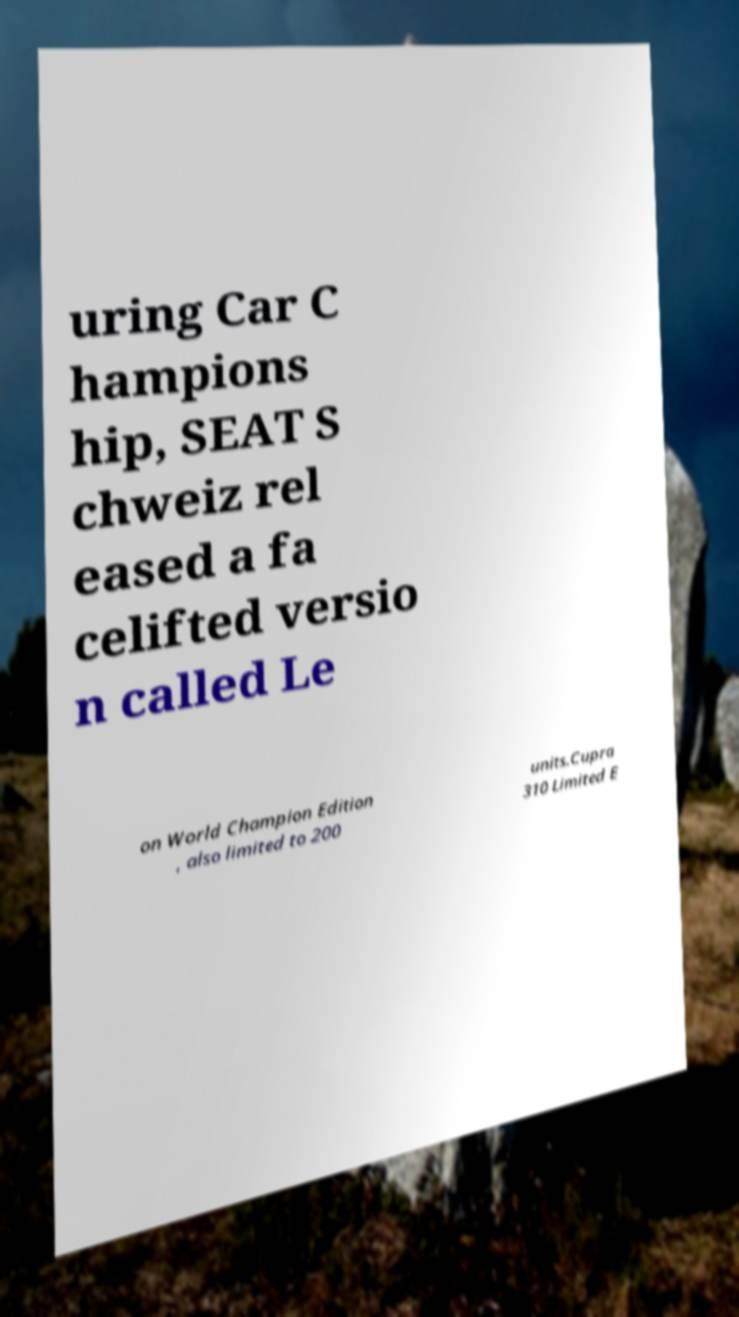I need the written content from this picture converted into text. Can you do that? uring Car C hampions hip, SEAT S chweiz rel eased a fa celifted versio n called Le on World Champion Edition , also limited to 200 units.Cupra 310 Limited E 